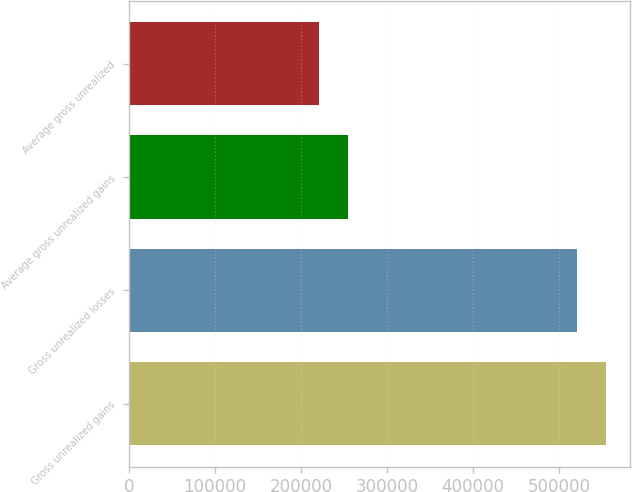Convert chart. <chart><loc_0><loc_0><loc_500><loc_500><bar_chart><fcel>Gross unrealized gains<fcel>Gross unrealized losses<fcel>Average gross unrealized gains<fcel>Average gross unrealized<nl><fcel>554151<fcel>521079<fcel>254471<fcel>221399<nl></chart> 